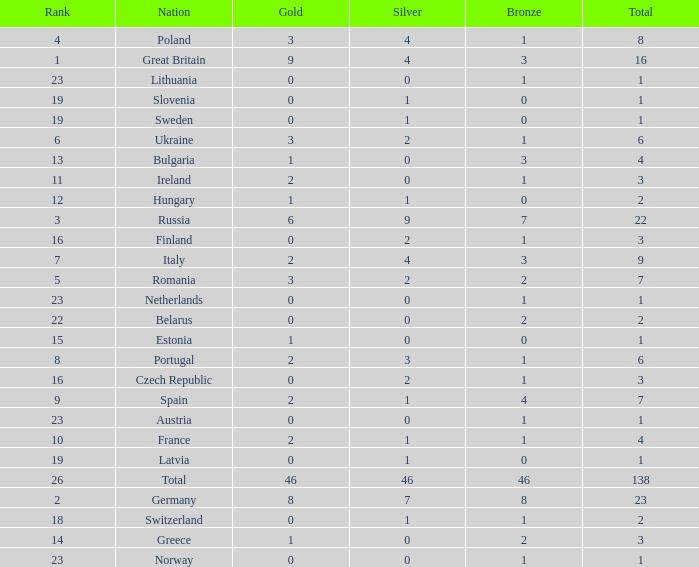What is the most bronze can be when silver is larger than 2, and the nation is germany, and gold is more than 8? None. 